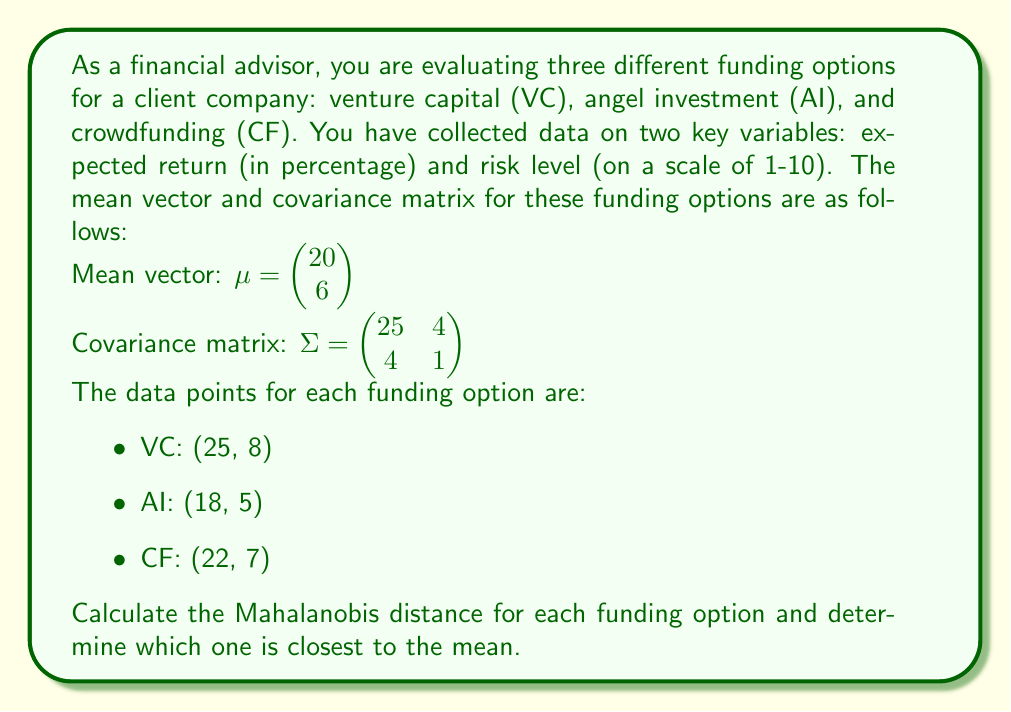Provide a solution to this math problem. To solve this problem, we'll follow these steps:

1. Recall the formula for Mahalanobis distance:
   $$ d = \sqrt{(x - \mu)^T \Sigma^{-1} (x - \mu)} $$

2. Calculate the inverse of the covariance matrix $\Sigma^{-1}$:
   $$ \Sigma^{-1} = \frac{1}{25 \cdot 1 - 4 \cdot 4} \begin{pmatrix} 1 & -4 \\ -4 & 25 \end{pmatrix} = \frac{1}{9} \begin{pmatrix} 1 & -4 \\ -4 & 25 \end{pmatrix} $$

3. For each funding option, calculate $(x - \mu)$:

   VC: $\begin{pmatrix} 25 - 20 \\ 8 - 6 \end{pmatrix} = \begin{pmatrix} 5 \\ 2 \end{pmatrix}$
   
   AI: $\begin{pmatrix} 18 - 20 \\ 5 - 6 \end{pmatrix} = \begin{pmatrix} -2 \\ -1 \end{pmatrix}$
   
   CF: $\begin{pmatrix} 22 - 20 \\ 7 - 6 \end{pmatrix} = \begin{pmatrix} 2 \\ 1 \end{pmatrix}$

4. Calculate the Mahalanobis distance for each option:

   VC: $d_{VC} = \sqrt{\begin{pmatrix} 5 & 2 \end{pmatrix} \frac{1}{9} \begin{pmatrix} 1 & -4 \\ -4 & 25 \end{pmatrix} \begin{pmatrix} 5 \\ 2 \end{pmatrix}}$
   
   $= \sqrt{\frac{1}{9}(5 \cdot 1 \cdot 5 + 5 \cdot -4 \cdot 2 + 2 \cdot -4 \cdot 5 + 2 \cdot 25 \cdot 2)} = \sqrt{\frac{1}{9}(25 - 40 - 40 + 100)} = \sqrt{\frac{45}{9}} = \sqrt{5} \approx 2.236$

   AI: $d_{AI} = \sqrt{\begin{pmatrix} -2 & -1 \end{pmatrix} \frac{1}{9} \begin{pmatrix} 1 & -4 \\ -4 & 25 \end{pmatrix} \begin{pmatrix} -2 \\ -1 \end{pmatrix}}$
   
   $= \sqrt{\frac{1}{9}(4 + 8 + 8 + 25)} = \sqrt{\frac{45}{9}} = \sqrt{5} \approx 2.236$

   CF: $d_{CF} = \sqrt{\begin{pmatrix} 2 & 1 \end{pmatrix} \frac{1}{9} \begin{pmatrix} 1 & -4 \\ -4 & 25 \end{pmatrix} \begin{pmatrix} 2 \\ 1 \end{pmatrix}}$
   
   $= \sqrt{\frac{1}{9}(4 - 8 - 8 + 25)} = \sqrt{\frac{13}{9}} \approx 1.202$

5. Compare the distances to determine which funding option is closest to the mean.
Answer: The Mahalanobis distances for each funding option are:

VC: $\sqrt{5} \approx 2.236$
AI: $\sqrt{5} \approx 2.236$
CF: $\sqrt{\frac{13}{9}} \approx 1.202$

The crowdfunding (CF) option has the smallest Mahalanobis distance, so it is closest to the mean. 